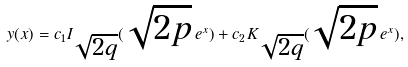<formula> <loc_0><loc_0><loc_500><loc_500>y ( x ) = c _ { 1 } I _ { \sqrt { 2 q } } ( \sqrt { 2 p } \, e ^ { x } ) + c _ { 2 } K _ { \sqrt { 2 q } } ( \sqrt { 2 p } \, e ^ { x } ) ,</formula> 